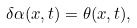<formula> <loc_0><loc_0><loc_500><loc_500>\delta \alpha ( x , t ) = \theta ( x , t ) ,</formula> 